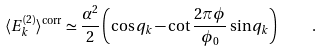<formula> <loc_0><loc_0><loc_500><loc_500>\langle E ^ { ( 2 ) } _ { k } \rangle ^ { \text {corr} } \simeq \frac { \alpha ^ { 2 } } { 2 } \left ( \cos q _ { k } - \cot \frac { 2 \pi \phi } { \phi _ { 0 } } \sin q _ { k } \right ) \quad .</formula> 